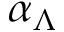Convert formula to latex. <formula><loc_0><loc_0><loc_500><loc_500>\alpha _ { \Lambda }</formula> 